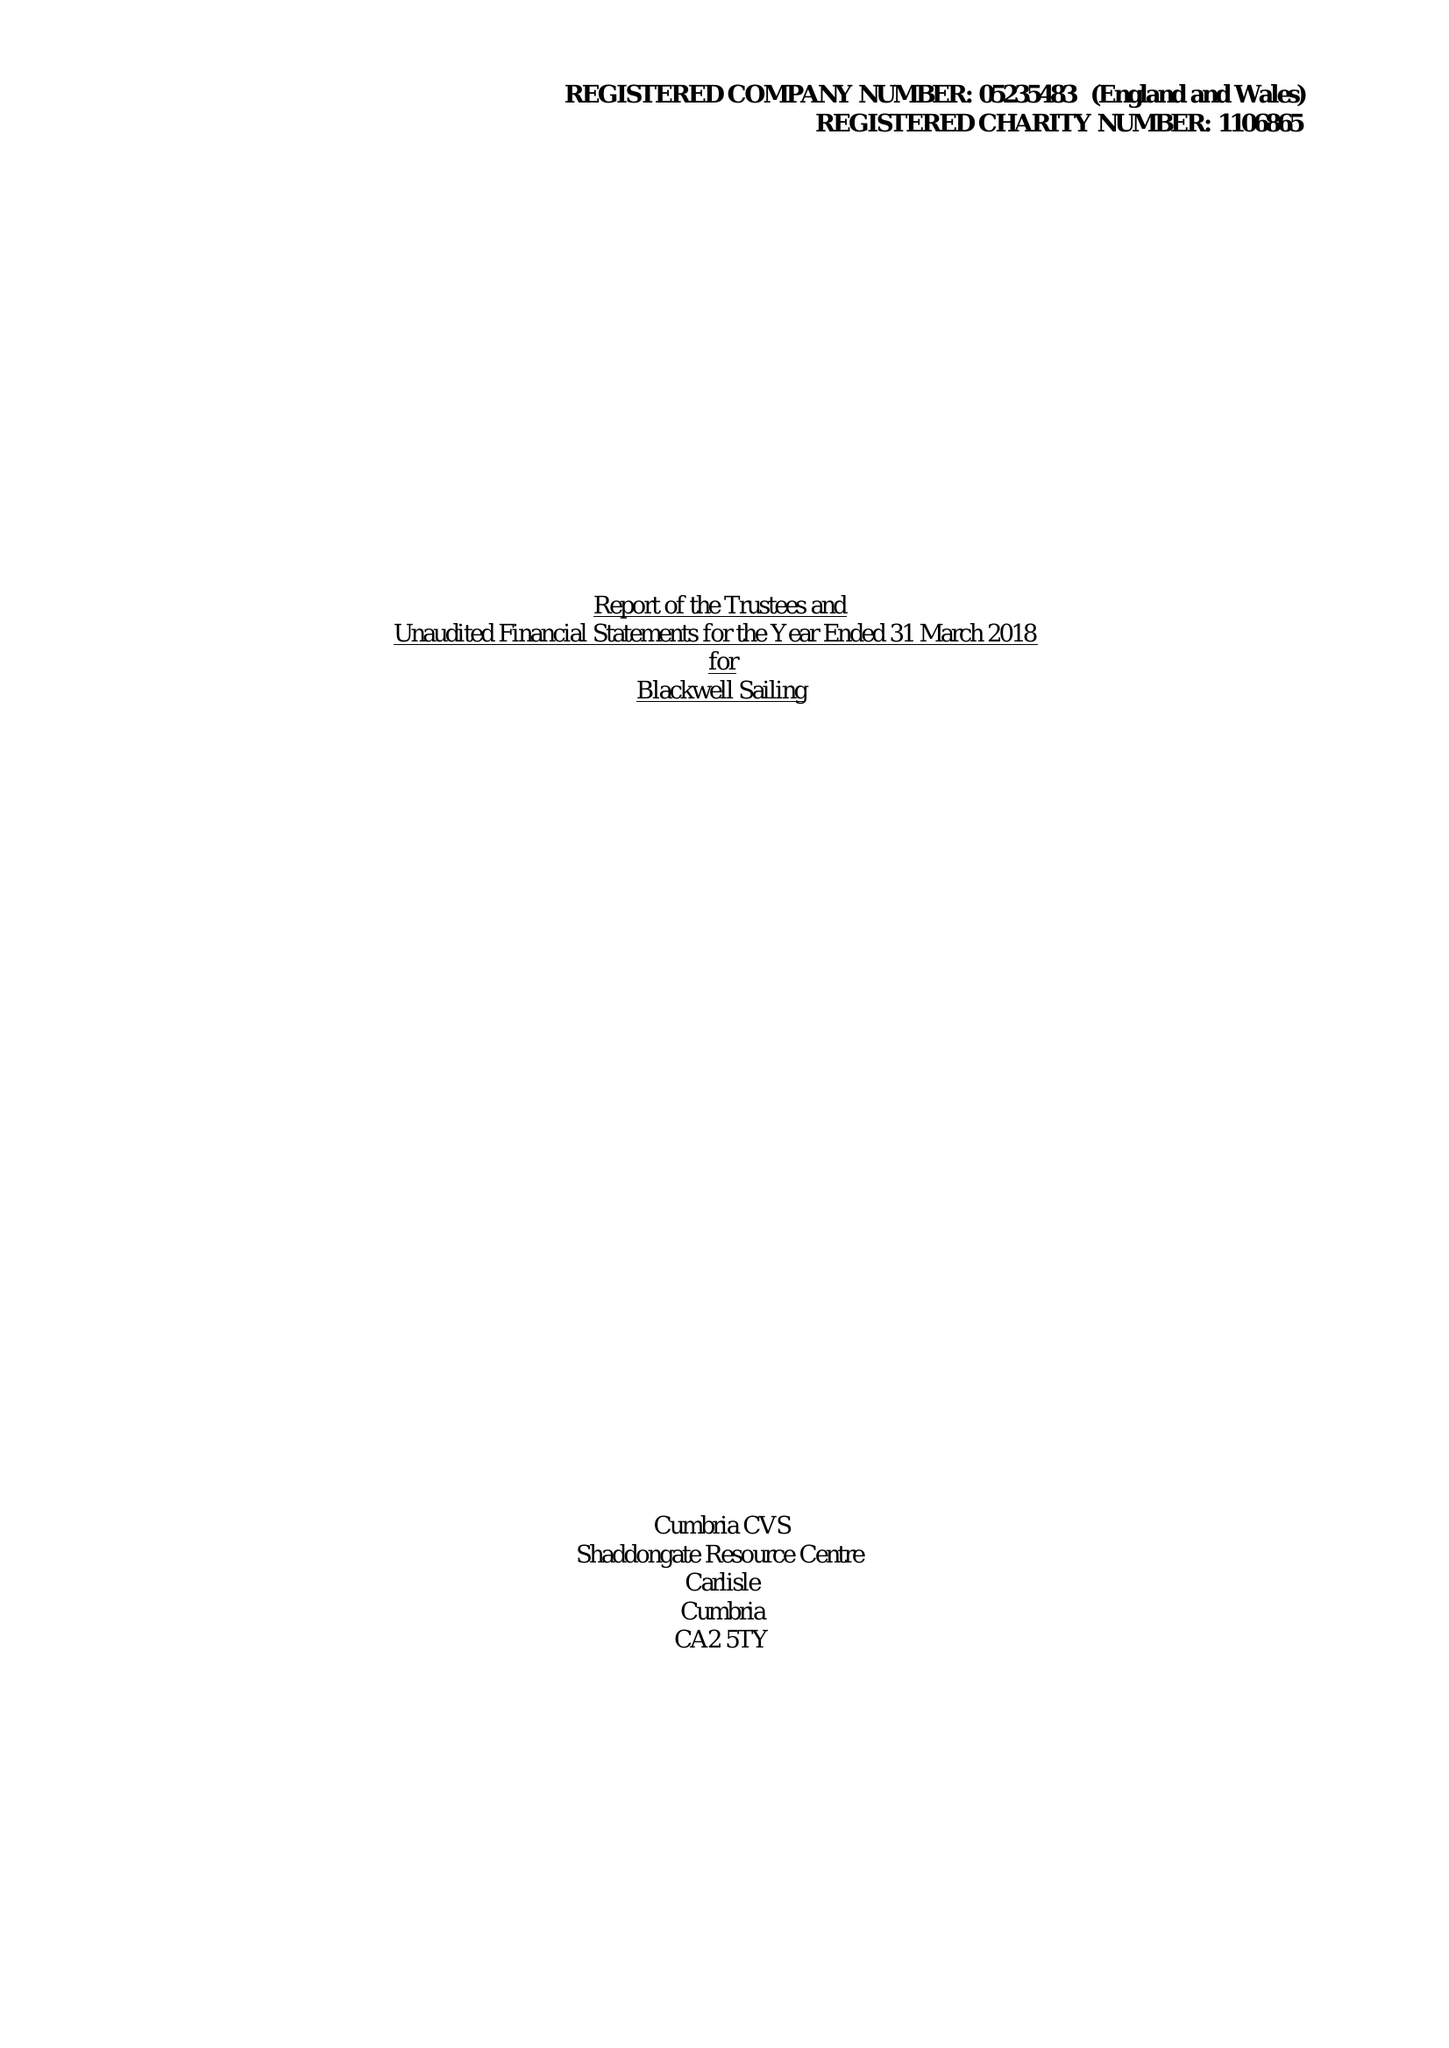What is the value for the income_annually_in_british_pounds?
Answer the question using a single word or phrase. 66459.00 